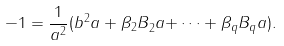Convert formula to latex. <formula><loc_0><loc_0><loc_500><loc_500>- 1 = \frac { 1 } { a ^ { 2 } } ( b ^ { 2 } a + { \beta _ { 2 } B } _ { 2 } a { + \dots + \beta _ { q } } B _ { q } a ) .</formula> 